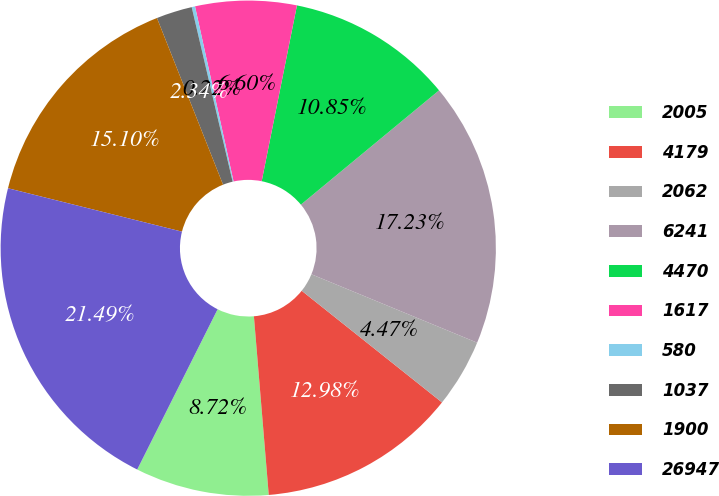Convert chart. <chart><loc_0><loc_0><loc_500><loc_500><pie_chart><fcel>2005<fcel>4179<fcel>2062<fcel>6241<fcel>4470<fcel>1617<fcel>580<fcel>1037<fcel>1900<fcel>26947<nl><fcel>8.72%<fcel>12.98%<fcel>4.47%<fcel>17.23%<fcel>10.85%<fcel>6.6%<fcel>0.22%<fcel>2.34%<fcel>15.1%<fcel>21.49%<nl></chart> 